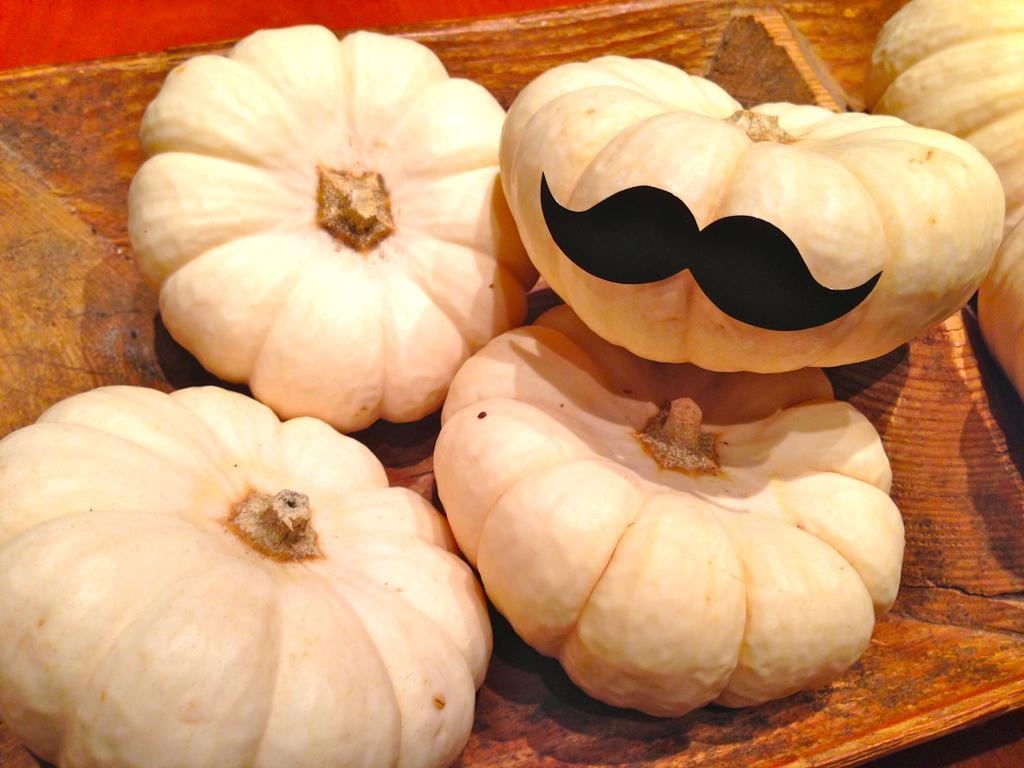Please provide a concise description of this image. This image consists of pumpkins kept in a wooden basket. It is kept on the floor. 